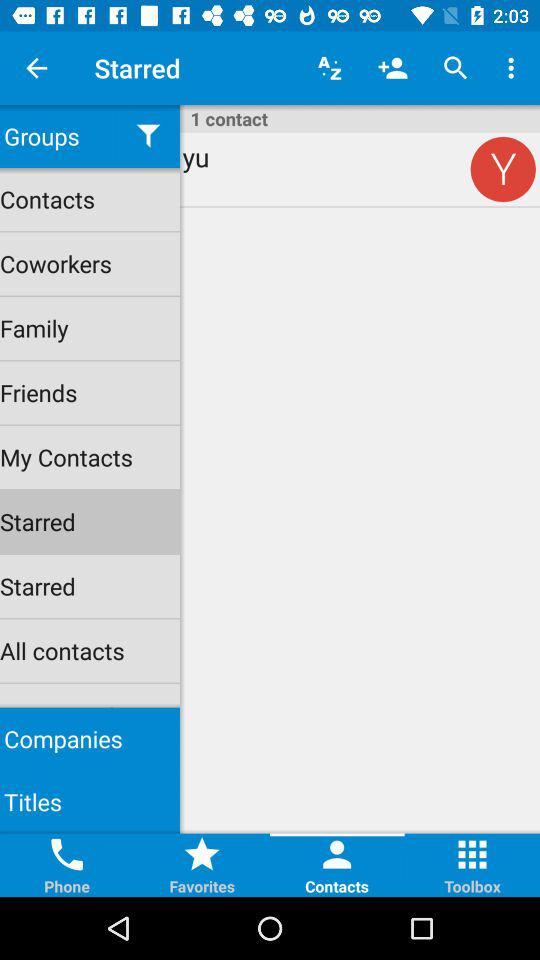How many contacts are there? There is 1 contact. 